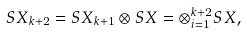<formula> <loc_0><loc_0><loc_500><loc_500>S X _ { k + 2 } = S X _ { k + 1 } \otimes S X = \otimes _ { i = 1 } ^ { k + 2 } S X ,</formula> 